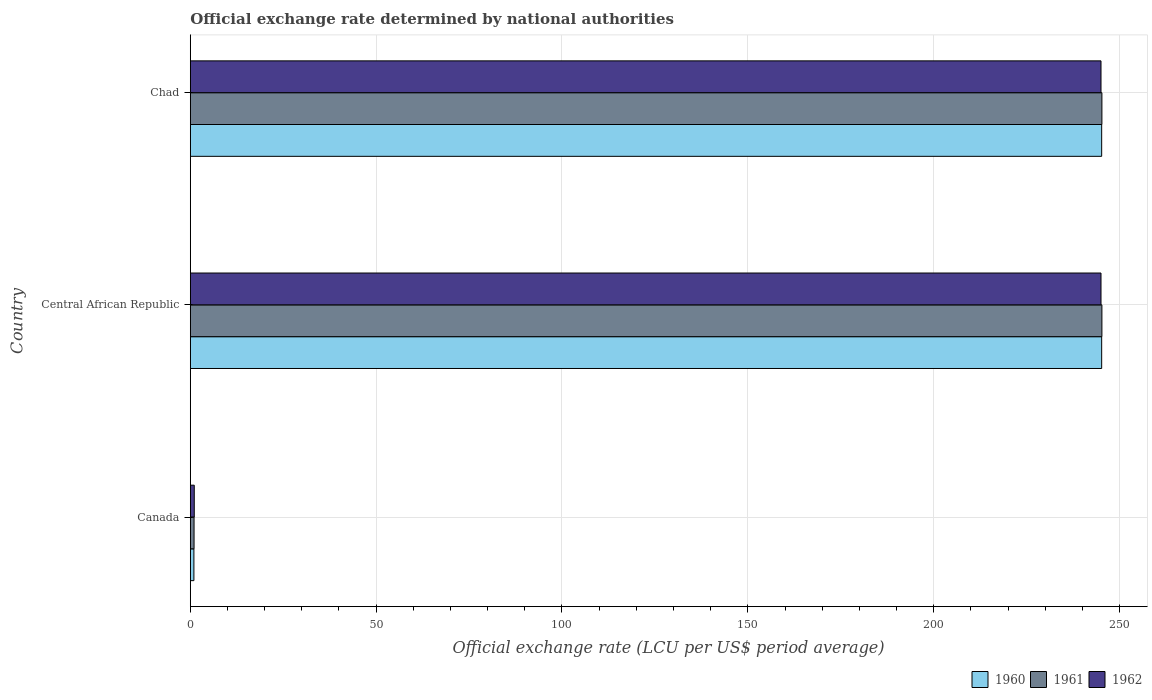How many different coloured bars are there?
Your answer should be compact. 3. How many groups of bars are there?
Give a very brief answer. 3. Are the number of bars per tick equal to the number of legend labels?
Offer a terse response. Yes. How many bars are there on the 2nd tick from the top?
Offer a very short reply. 3. How many bars are there on the 1st tick from the bottom?
Your answer should be compact. 3. What is the label of the 3rd group of bars from the top?
Your response must be concise. Canada. What is the official exchange rate in 1962 in Chad?
Offer a terse response. 245.01. Across all countries, what is the maximum official exchange rate in 1960?
Keep it short and to the point. 245.2. Across all countries, what is the minimum official exchange rate in 1960?
Your answer should be compact. 0.97. In which country was the official exchange rate in 1961 maximum?
Keep it short and to the point. Central African Republic. In which country was the official exchange rate in 1960 minimum?
Provide a short and direct response. Canada. What is the total official exchange rate in 1960 in the graph?
Your answer should be very brief. 491.36. What is the difference between the official exchange rate in 1961 in Canada and that in Central African Republic?
Ensure brevity in your answer.  -244.25. What is the difference between the official exchange rate in 1961 in Central African Republic and the official exchange rate in 1960 in Chad?
Your answer should be compact. 0.07. What is the average official exchange rate in 1960 per country?
Your answer should be very brief. 163.79. What is the difference between the official exchange rate in 1962 and official exchange rate in 1961 in Central African Republic?
Provide a succinct answer. -0.25. Is the official exchange rate in 1962 in Central African Republic less than that in Chad?
Give a very brief answer. Yes. Is the difference between the official exchange rate in 1962 in Canada and Central African Republic greater than the difference between the official exchange rate in 1961 in Canada and Central African Republic?
Ensure brevity in your answer.  Yes. What is the difference between the highest and the second highest official exchange rate in 1962?
Provide a short and direct response. 9.947598300641403e-13. What is the difference between the highest and the lowest official exchange rate in 1961?
Keep it short and to the point. 244.25. In how many countries, is the official exchange rate in 1962 greater than the average official exchange rate in 1962 taken over all countries?
Your answer should be compact. 2. Is the sum of the official exchange rate in 1961 in Canada and Chad greater than the maximum official exchange rate in 1962 across all countries?
Ensure brevity in your answer.  Yes. What does the 3rd bar from the bottom in Canada represents?
Keep it short and to the point. 1962. Is it the case that in every country, the sum of the official exchange rate in 1961 and official exchange rate in 1960 is greater than the official exchange rate in 1962?
Your response must be concise. Yes. Are all the bars in the graph horizontal?
Ensure brevity in your answer.  Yes. How many countries are there in the graph?
Make the answer very short. 3. What is the difference between two consecutive major ticks on the X-axis?
Give a very brief answer. 50. Are the values on the major ticks of X-axis written in scientific E-notation?
Your answer should be very brief. No. How many legend labels are there?
Keep it short and to the point. 3. What is the title of the graph?
Keep it short and to the point. Official exchange rate determined by national authorities. What is the label or title of the X-axis?
Offer a terse response. Official exchange rate (LCU per US$ period average). What is the Official exchange rate (LCU per US$ period average) of 1960 in Canada?
Your answer should be compact. 0.97. What is the Official exchange rate (LCU per US$ period average) in 1961 in Canada?
Provide a succinct answer. 1.01. What is the Official exchange rate (LCU per US$ period average) of 1962 in Canada?
Your answer should be very brief. 1.07. What is the Official exchange rate (LCU per US$ period average) in 1960 in Central African Republic?
Offer a terse response. 245.2. What is the Official exchange rate (LCU per US$ period average) in 1961 in Central African Republic?
Your response must be concise. 245.26. What is the Official exchange rate (LCU per US$ period average) of 1962 in Central African Republic?
Offer a very short reply. 245.01. What is the Official exchange rate (LCU per US$ period average) in 1960 in Chad?
Ensure brevity in your answer.  245.2. What is the Official exchange rate (LCU per US$ period average) of 1961 in Chad?
Ensure brevity in your answer.  245.26. What is the Official exchange rate (LCU per US$ period average) of 1962 in Chad?
Offer a very short reply. 245.01. Across all countries, what is the maximum Official exchange rate (LCU per US$ period average) of 1960?
Provide a succinct answer. 245.2. Across all countries, what is the maximum Official exchange rate (LCU per US$ period average) in 1961?
Keep it short and to the point. 245.26. Across all countries, what is the maximum Official exchange rate (LCU per US$ period average) of 1962?
Your answer should be compact. 245.01. Across all countries, what is the minimum Official exchange rate (LCU per US$ period average) of 1960?
Your answer should be very brief. 0.97. Across all countries, what is the minimum Official exchange rate (LCU per US$ period average) of 1961?
Make the answer very short. 1.01. Across all countries, what is the minimum Official exchange rate (LCU per US$ period average) of 1962?
Ensure brevity in your answer.  1.07. What is the total Official exchange rate (LCU per US$ period average) of 1960 in the graph?
Offer a terse response. 491.36. What is the total Official exchange rate (LCU per US$ period average) in 1961 in the graph?
Keep it short and to the point. 491.53. What is the total Official exchange rate (LCU per US$ period average) in 1962 in the graph?
Your answer should be very brief. 491.1. What is the difference between the Official exchange rate (LCU per US$ period average) of 1960 in Canada and that in Central African Republic?
Offer a terse response. -244.23. What is the difference between the Official exchange rate (LCU per US$ period average) of 1961 in Canada and that in Central African Republic?
Provide a short and direct response. -244.25. What is the difference between the Official exchange rate (LCU per US$ period average) in 1962 in Canada and that in Central African Republic?
Provide a succinct answer. -243.95. What is the difference between the Official exchange rate (LCU per US$ period average) of 1960 in Canada and that in Chad?
Provide a short and direct response. -244.23. What is the difference between the Official exchange rate (LCU per US$ period average) of 1961 in Canada and that in Chad?
Provide a succinct answer. -244.25. What is the difference between the Official exchange rate (LCU per US$ period average) in 1962 in Canada and that in Chad?
Make the answer very short. -243.95. What is the difference between the Official exchange rate (LCU per US$ period average) of 1960 in Central African Republic and that in Chad?
Provide a succinct answer. 0. What is the difference between the Official exchange rate (LCU per US$ period average) of 1962 in Central African Republic and that in Chad?
Ensure brevity in your answer.  -0. What is the difference between the Official exchange rate (LCU per US$ period average) in 1960 in Canada and the Official exchange rate (LCU per US$ period average) in 1961 in Central African Republic?
Keep it short and to the point. -244.29. What is the difference between the Official exchange rate (LCU per US$ period average) of 1960 in Canada and the Official exchange rate (LCU per US$ period average) of 1962 in Central African Republic?
Ensure brevity in your answer.  -244.04. What is the difference between the Official exchange rate (LCU per US$ period average) of 1961 in Canada and the Official exchange rate (LCU per US$ period average) of 1962 in Central African Republic?
Offer a terse response. -244. What is the difference between the Official exchange rate (LCU per US$ period average) in 1960 in Canada and the Official exchange rate (LCU per US$ period average) in 1961 in Chad?
Your answer should be compact. -244.29. What is the difference between the Official exchange rate (LCU per US$ period average) in 1960 in Canada and the Official exchange rate (LCU per US$ period average) in 1962 in Chad?
Your response must be concise. -244.04. What is the difference between the Official exchange rate (LCU per US$ period average) in 1961 in Canada and the Official exchange rate (LCU per US$ period average) in 1962 in Chad?
Your answer should be compact. -244. What is the difference between the Official exchange rate (LCU per US$ period average) of 1960 in Central African Republic and the Official exchange rate (LCU per US$ period average) of 1961 in Chad?
Your response must be concise. -0.07. What is the difference between the Official exchange rate (LCU per US$ period average) of 1960 in Central African Republic and the Official exchange rate (LCU per US$ period average) of 1962 in Chad?
Provide a short and direct response. 0.18. What is the difference between the Official exchange rate (LCU per US$ period average) of 1961 in Central African Republic and the Official exchange rate (LCU per US$ period average) of 1962 in Chad?
Offer a terse response. 0.25. What is the average Official exchange rate (LCU per US$ period average) in 1960 per country?
Make the answer very short. 163.79. What is the average Official exchange rate (LCU per US$ period average) in 1961 per country?
Your response must be concise. 163.84. What is the average Official exchange rate (LCU per US$ period average) in 1962 per country?
Your response must be concise. 163.7. What is the difference between the Official exchange rate (LCU per US$ period average) in 1960 and Official exchange rate (LCU per US$ period average) in 1961 in Canada?
Your answer should be compact. -0.04. What is the difference between the Official exchange rate (LCU per US$ period average) in 1960 and Official exchange rate (LCU per US$ period average) in 1962 in Canada?
Provide a succinct answer. -0.1. What is the difference between the Official exchange rate (LCU per US$ period average) in 1961 and Official exchange rate (LCU per US$ period average) in 1962 in Canada?
Provide a succinct answer. -0.06. What is the difference between the Official exchange rate (LCU per US$ period average) of 1960 and Official exchange rate (LCU per US$ period average) of 1961 in Central African Republic?
Your answer should be compact. -0.07. What is the difference between the Official exchange rate (LCU per US$ period average) in 1960 and Official exchange rate (LCU per US$ period average) in 1962 in Central African Republic?
Ensure brevity in your answer.  0.18. What is the difference between the Official exchange rate (LCU per US$ period average) of 1961 and Official exchange rate (LCU per US$ period average) of 1962 in Central African Republic?
Your answer should be very brief. 0.25. What is the difference between the Official exchange rate (LCU per US$ period average) of 1960 and Official exchange rate (LCU per US$ period average) of 1961 in Chad?
Offer a very short reply. -0.07. What is the difference between the Official exchange rate (LCU per US$ period average) in 1960 and Official exchange rate (LCU per US$ period average) in 1962 in Chad?
Your response must be concise. 0.18. What is the difference between the Official exchange rate (LCU per US$ period average) in 1961 and Official exchange rate (LCU per US$ period average) in 1962 in Chad?
Your response must be concise. 0.25. What is the ratio of the Official exchange rate (LCU per US$ period average) of 1960 in Canada to that in Central African Republic?
Provide a short and direct response. 0. What is the ratio of the Official exchange rate (LCU per US$ period average) in 1961 in Canada to that in Central African Republic?
Keep it short and to the point. 0. What is the ratio of the Official exchange rate (LCU per US$ period average) in 1962 in Canada to that in Central African Republic?
Keep it short and to the point. 0. What is the ratio of the Official exchange rate (LCU per US$ period average) in 1960 in Canada to that in Chad?
Provide a succinct answer. 0. What is the ratio of the Official exchange rate (LCU per US$ period average) of 1961 in Canada to that in Chad?
Provide a succinct answer. 0. What is the ratio of the Official exchange rate (LCU per US$ period average) of 1962 in Canada to that in Chad?
Ensure brevity in your answer.  0. What is the ratio of the Official exchange rate (LCU per US$ period average) of 1961 in Central African Republic to that in Chad?
Your answer should be very brief. 1. What is the ratio of the Official exchange rate (LCU per US$ period average) of 1962 in Central African Republic to that in Chad?
Offer a very short reply. 1. What is the difference between the highest and the second highest Official exchange rate (LCU per US$ period average) of 1960?
Provide a succinct answer. 0. What is the difference between the highest and the second highest Official exchange rate (LCU per US$ period average) of 1962?
Your response must be concise. 0. What is the difference between the highest and the lowest Official exchange rate (LCU per US$ period average) of 1960?
Offer a very short reply. 244.23. What is the difference between the highest and the lowest Official exchange rate (LCU per US$ period average) in 1961?
Your answer should be compact. 244.25. What is the difference between the highest and the lowest Official exchange rate (LCU per US$ period average) in 1962?
Ensure brevity in your answer.  243.95. 